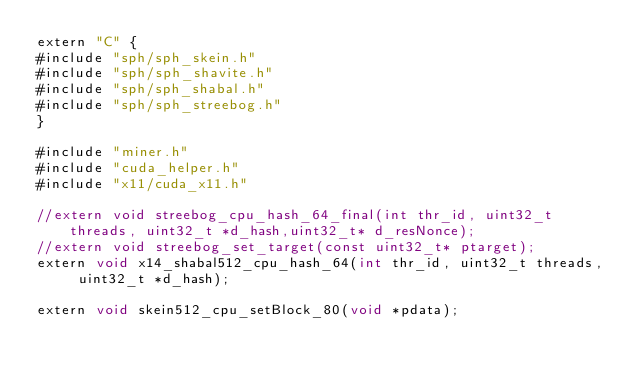<code> <loc_0><loc_0><loc_500><loc_500><_Cuda_>extern "C" {
#include "sph/sph_skein.h"
#include "sph/sph_shavite.h"
#include "sph/sph_shabal.h"
#include "sph/sph_streebog.h"
}

#include "miner.h"
#include "cuda_helper.h"
#include "x11/cuda_x11.h"

//extern void streebog_cpu_hash_64_final(int thr_id, uint32_t threads, uint32_t *d_hash,uint32_t* d_resNonce);
//extern void streebog_set_target(const uint32_t* ptarget);
extern void x14_shabal512_cpu_hash_64(int thr_id, uint32_t threads, uint32_t *d_hash);

extern void skein512_cpu_setBlock_80(void *pdata);</code> 